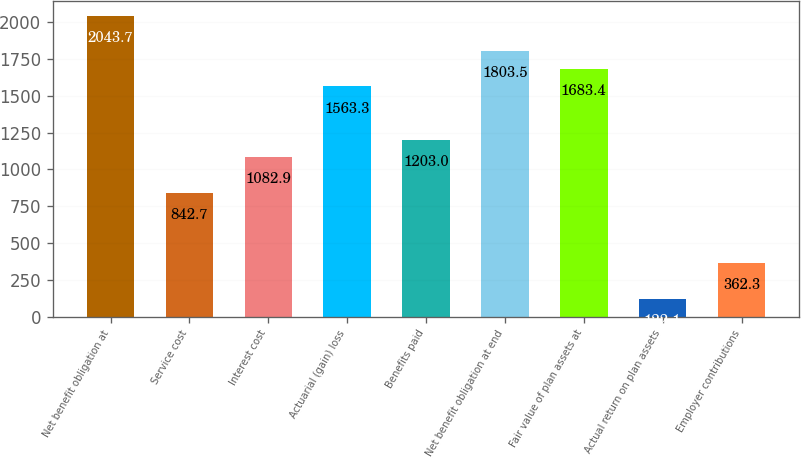<chart> <loc_0><loc_0><loc_500><loc_500><bar_chart><fcel>Net benefit obligation at<fcel>Service cost<fcel>Interest cost<fcel>Actuarial (gain) loss<fcel>Benefits paid<fcel>Net benefit obligation at end<fcel>Fair value of plan assets at<fcel>Actual return on plan assets<fcel>Employer contributions<nl><fcel>2043.7<fcel>842.7<fcel>1082.9<fcel>1563.3<fcel>1203<fcel>1803.5<fcel>1683.4<fcel>122.1<fcel>362.3<nl></chart> 